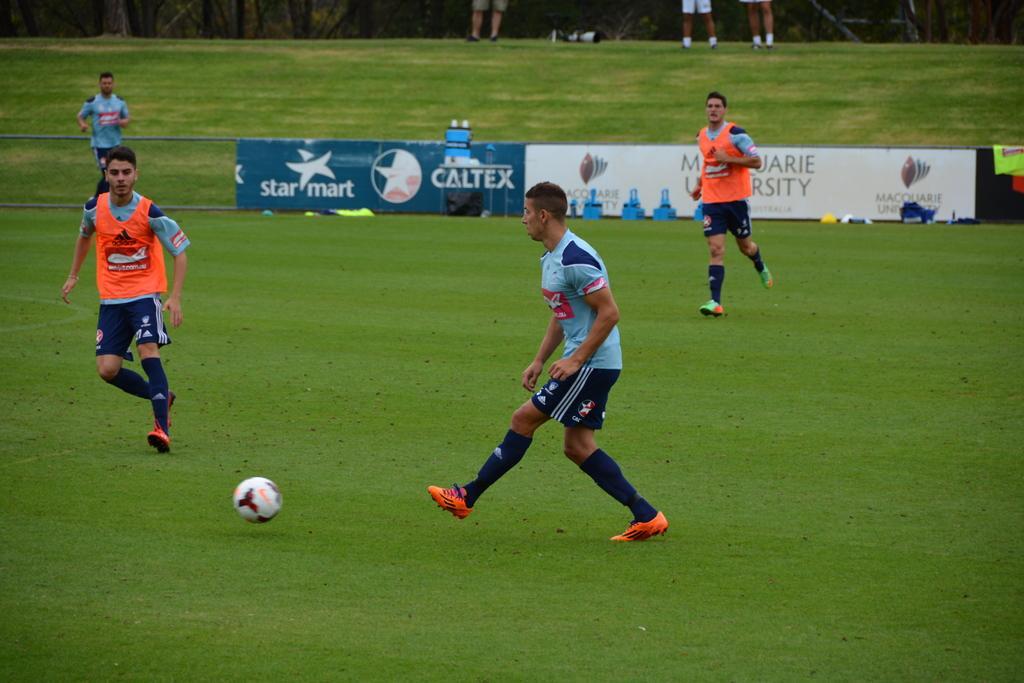Could you give a brief overview of what you see in this image? In the picture we can see a playground with a grass surface on it, we can see some people are playing football and they are wearing a sportswear and in the background, we can see an advertisement board on the ground and behind it we can see some people are standing. 